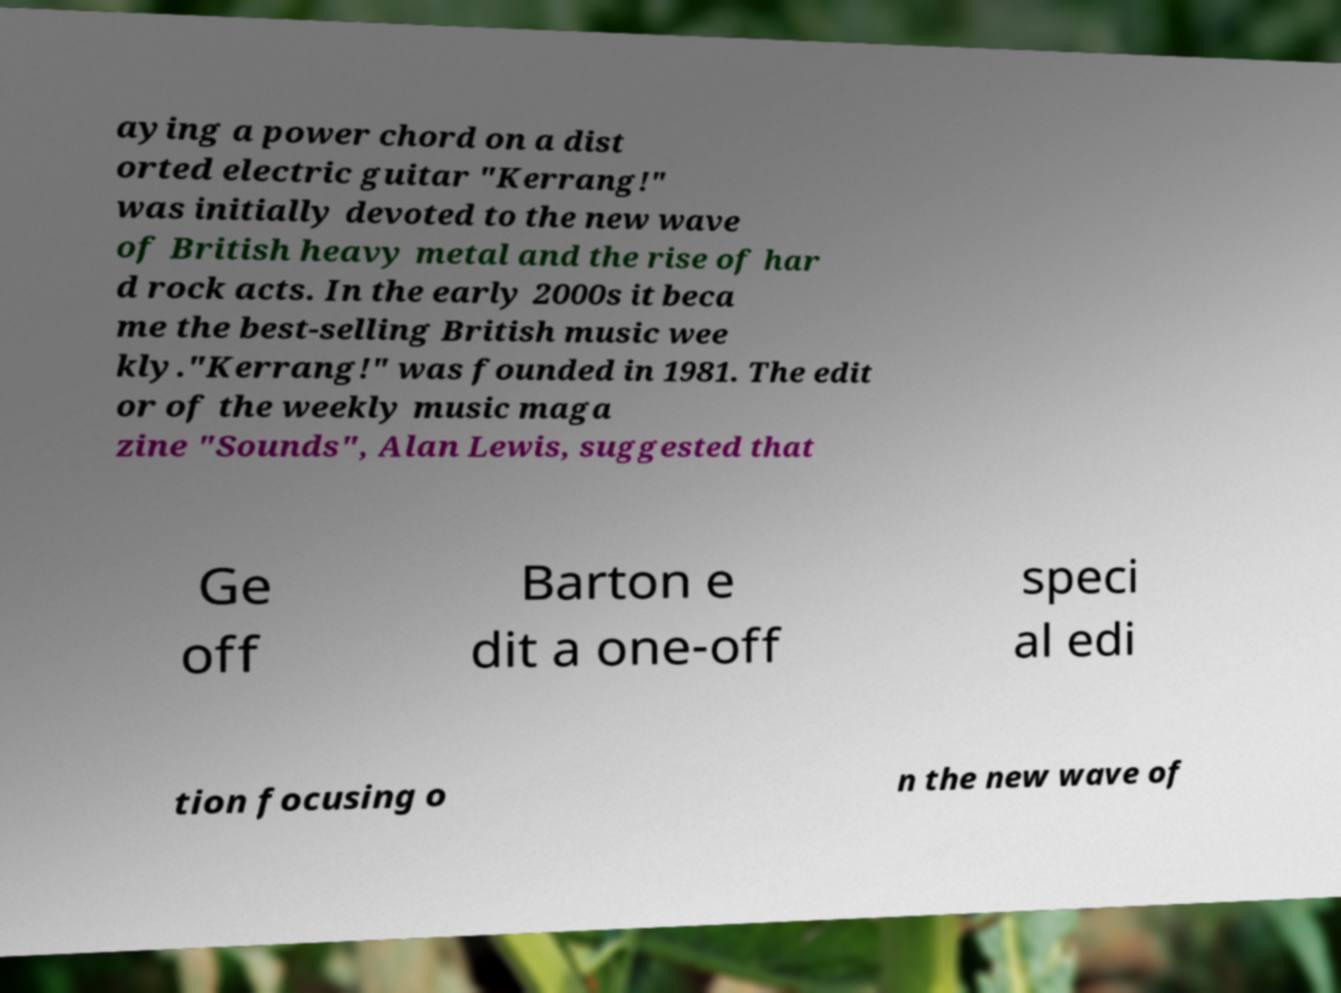I need the written content from this picture converted into text. Can you do that? aying a power chord on a dist orted electric guitar "Kerrang!" was initially devoted to the new wave of British heavy metal and the rise of har d rock acts. In the early 2000s it beca me the best-selling British music wee kly."Kerrang!" was founded in 1981. The edit or of the weekly music maga zine "Sounds", Alan Lewis, suggested that Ge off Barton e dit a one-off speci al edi tion focusing o n the new wave of 